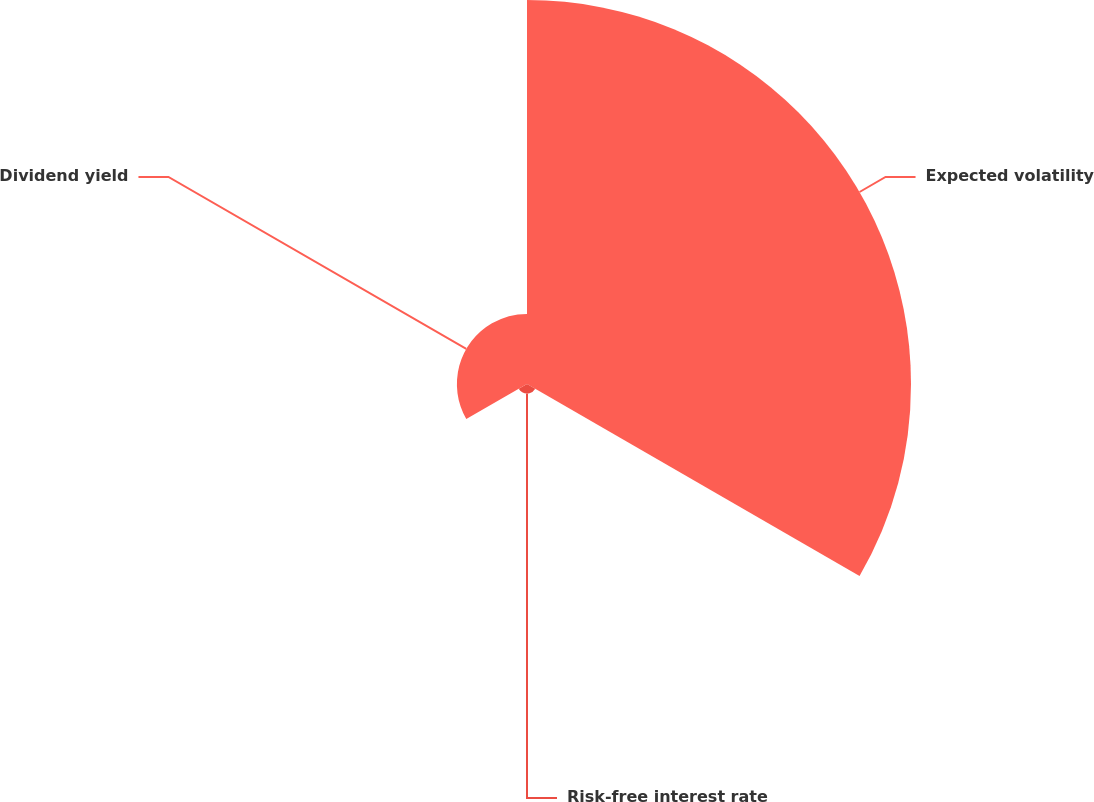<chart> <loc_0><loc_0><loc_500><loc_500><pie_chart><fcel>Expected volatility<fcel>Risk-free interest rate<fcel>Dividend yield<nl><fcel>82.82%<fcel>2.06%<fcel>15.12%<nl></chart> 